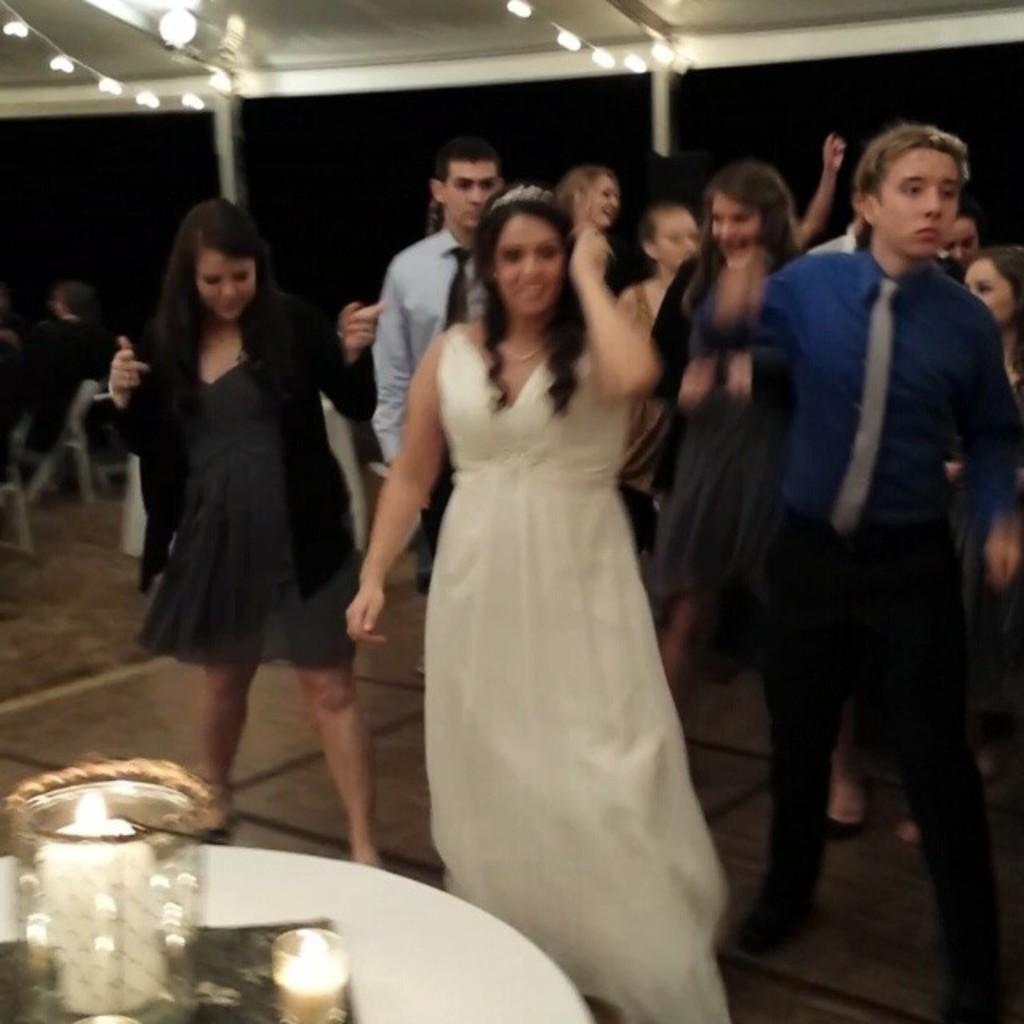What are the people in the image doing? The people in the image are dancing. What else can be seen in the image besides the dancing people? There is a table in the image. Are there any decorative items on the table? Yes, there are two candles on the table. Where is the yak in the image? There is no yak present in the image. What type of vase can be seen holding the candles on the table? There is no vase present in the image; the candles are directly on the table. 